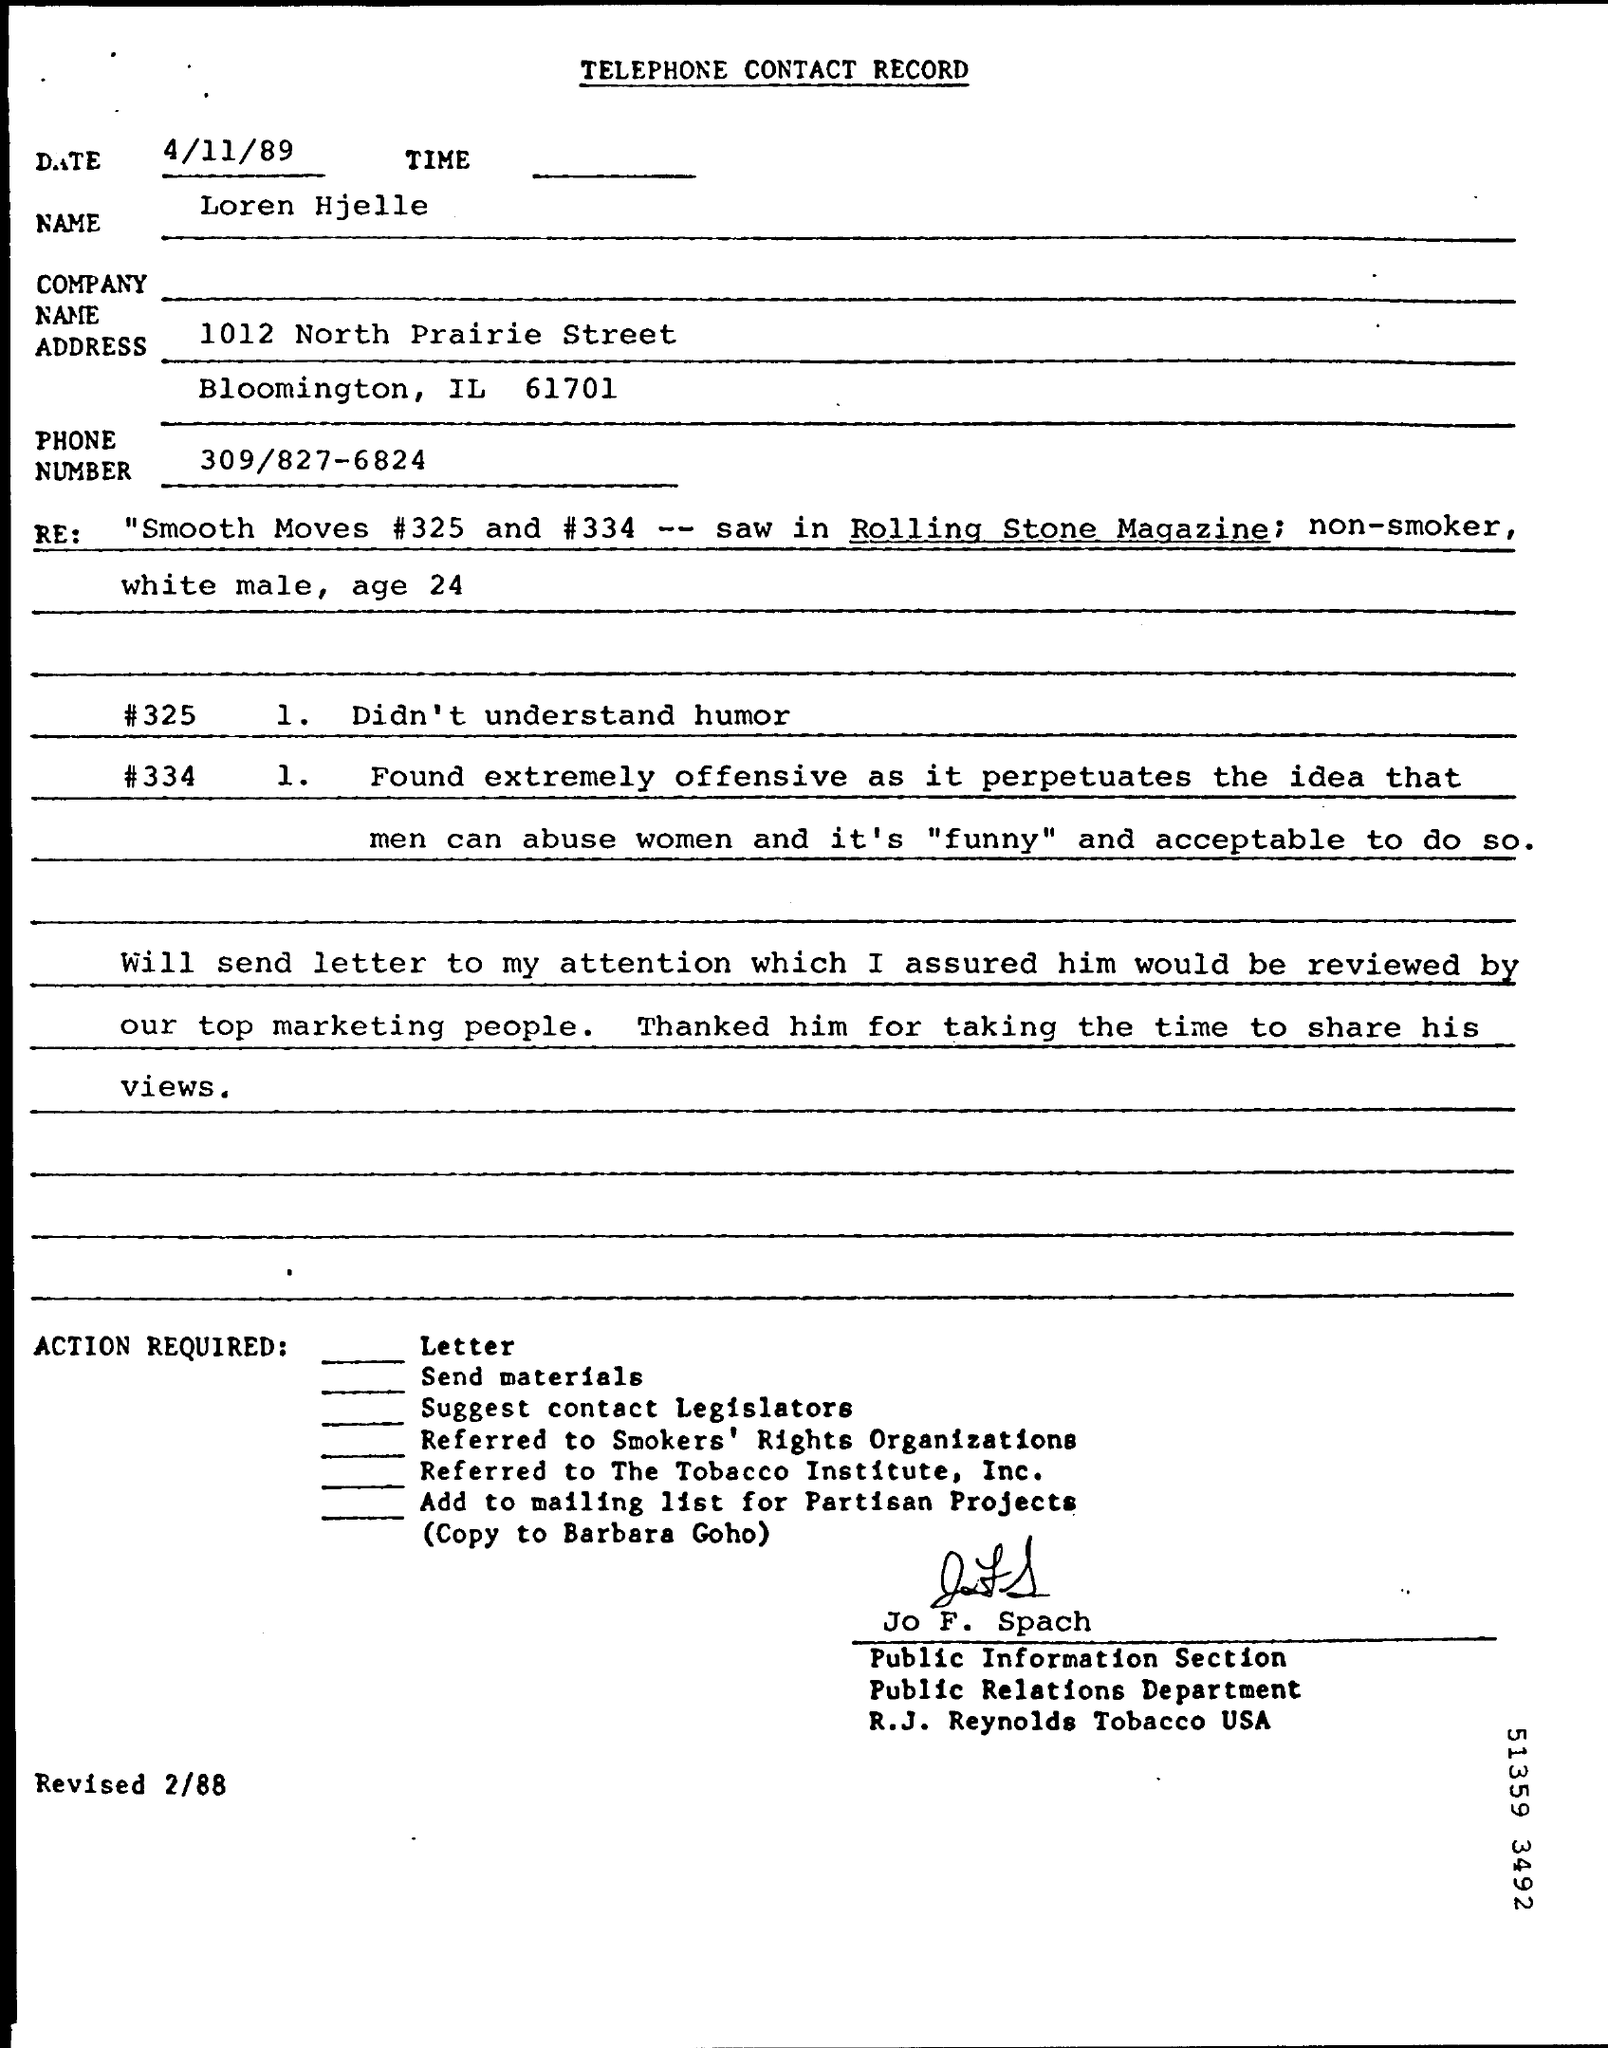Identify some key points in this picture. The letter is from Jo F. Spach. Loren Hjelle is the name. The phone number is 309/827-6824. The date is April 11th, 1989. The title of the document is 'Telephone Contact Record.' 